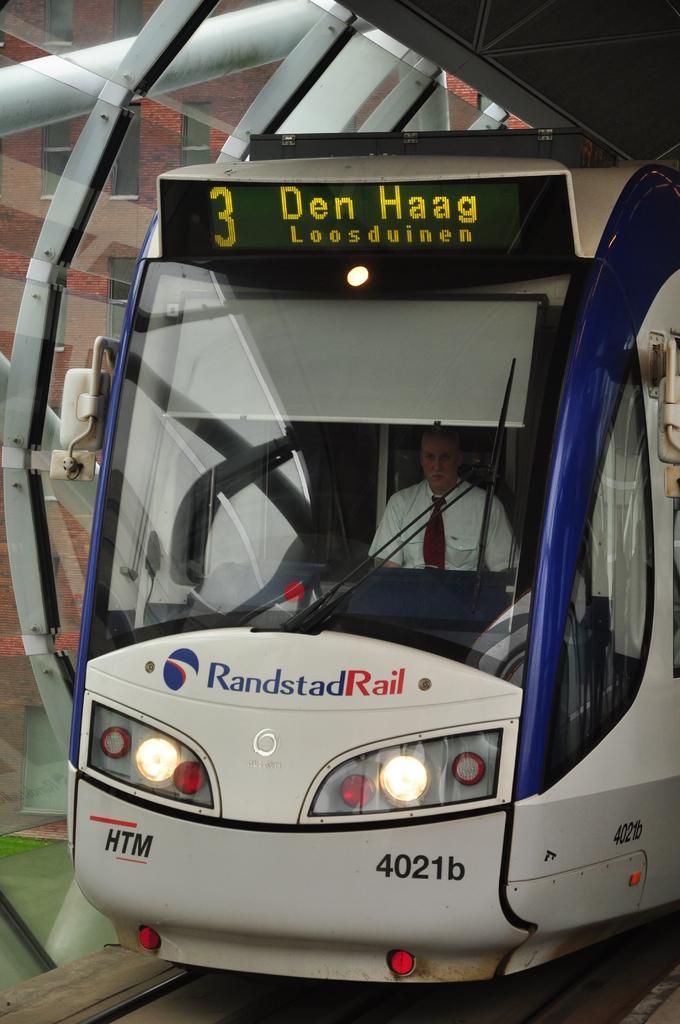Please provide a concise description of this image. In this image we can see a person wearing a white shirt and tie is sitting in a vehicle, with set of lights, a sign board. In the background, we can see a group of poles, building and a shed. 